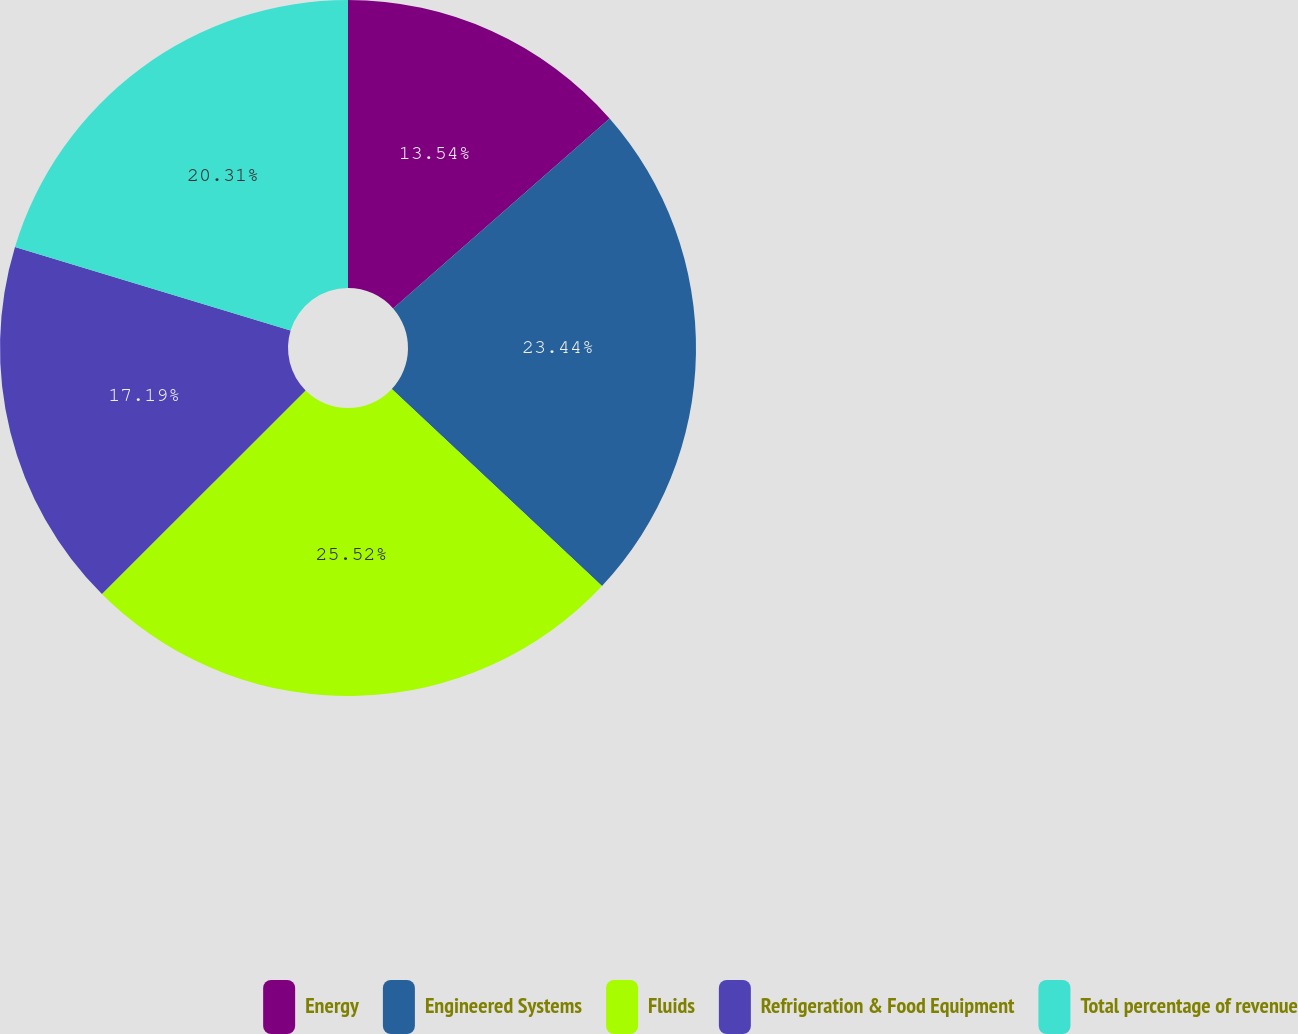Convert chart to OTSL. <chart><loc_0><loc_0><loc_500><loc_500><pie_chart><fcel>Energy<fcel>Engineered Systems<fcel>Fluids<fcel>Refrigeration & Food Equipment<fcel>Total percentage of revenue<nl><fcel>13.54%<fcel>23.44%<fcel>25.52%<fcel>17.19%<fcel>20.31%<nl></chart> 